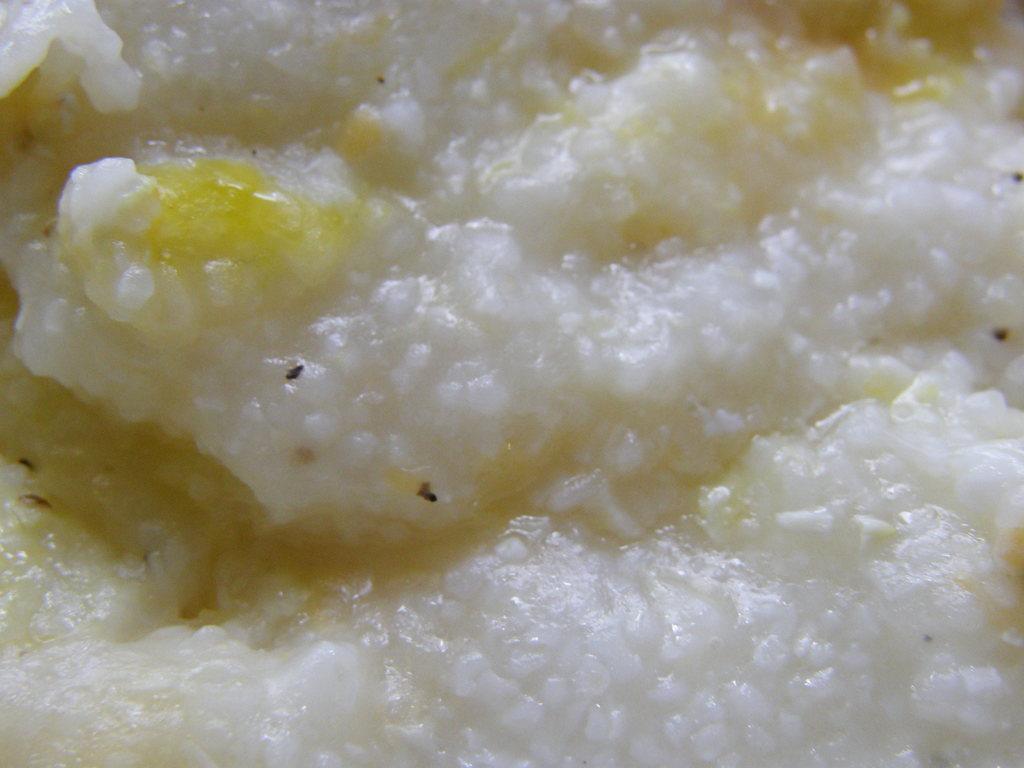In one or two sentences, can you explain what this image depicts? In this image I can see a food item which is white and yellow in color. 